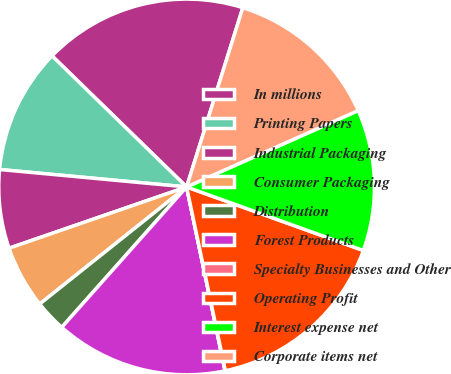<chart> <loc_0><loc_0><loc_500><loc_500><pie_chart><fcel>In millions<fcel>Printing Papers<fcel>Industrial Packaging<fcel>Consumer Packaging<fcel>Distribution<fcel>Forest Products<fcel>Specialty Businesses and Other<fcel>Operating Profit<fcel>Interest expense net<fcel>Corporate items net<nl><fcel>17.55%<fcel>10.81%<fcel>6.77%<fcel>5.42%<fcel>2.72%<fcel>14.85%<fcel>0.03%<fcel>16.2%<fcel>12.16%<fcel>13.5%<nl></chart> 